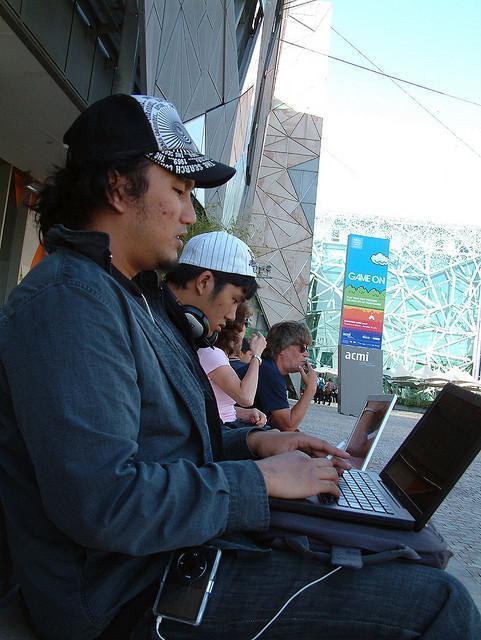How many people in the shot?
Give a very brief answer. 4. How many people are shown?
Give a very brief answer. 4. How many people are there?
Give a very brief answer. 4. How many laptops can be seen?
Give a very brief answer. 2. How many engine cars are there before the light gray container car?
Give a very brief answer. 0. 